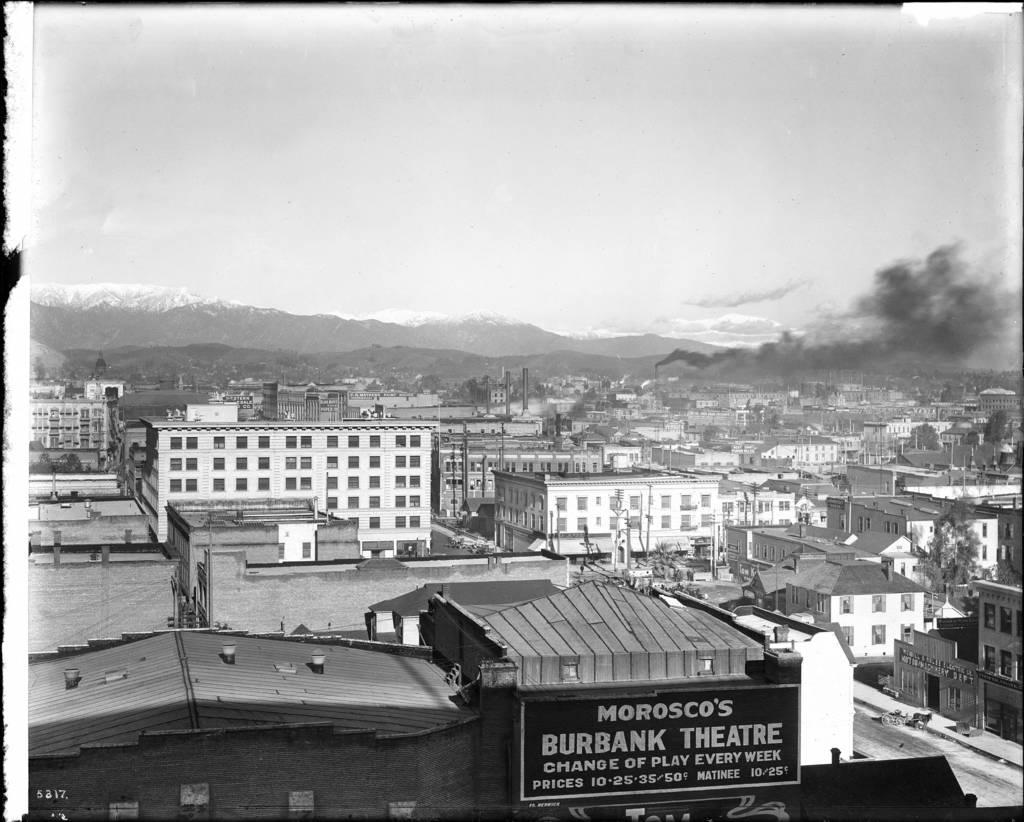<image>
Share a concise interpretation of the image provided. An aerial view of a town with Morosco's Burbank Theatre. 